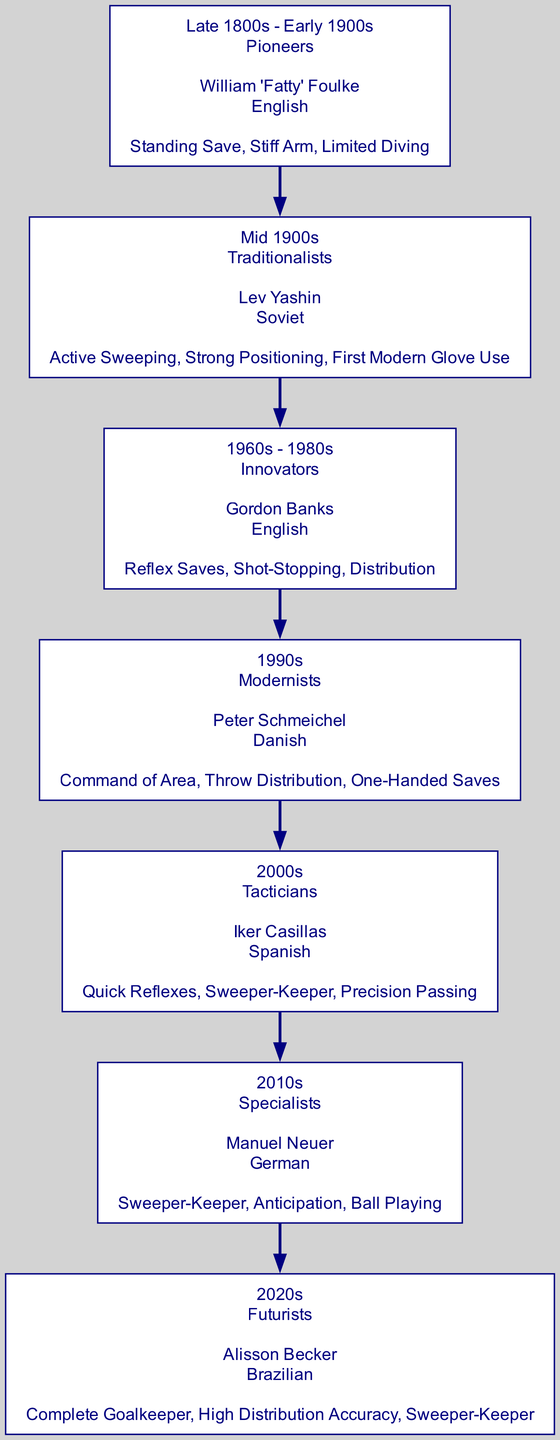What is the technique associated with William 'Fatty' Foulke? The diagram shows that William 'Fatty' Foulke is associated with the techniques: Standing Save, Stiff Arm, Limited Diving, listed under the "Late 1800s - Early 1900s" era.
Answer: Standing Save, Stiff Arm, Limited Diving Who is identified as the Innovator in goalkeeping? According to the diagram, Gordon Banks is presented as the Innovator in the 1960s - 1980s era, where he is recognized for his contributions to goalkeeping.
Answer: Gordon Banks Which goalkeeper is noted for using the first modern gloves? The diagram indicates that Lev Yashin, a Traditionalist from the Mid 1900s, is noted for using the first modern gloves in goalkeeping.
Answer: Lev Yashin How many eras are represented in the diagram? By examining the diagram, we can count a total of seven distinct eras from the Late 1800s - Early 1900s to the 2020s, each represented in the family tree.
Answer: 7 What is the shared technique between Manuel Neuer and Iker Casillas? The diagram highlights that both Manuel Neuer and Iker Casillas are associated with the technique of "Sweeper-Keeper," thus demonstrating a commonality in their approach to goalkeeping.
Answer: Sweeper-Keeper Who is the Futurist goalkeeper in the diagram? The diagram specifies Alisson Becker as the Futurist goalkeeper in the 2020s, showcasing his contemporary techniques.
Answer: Alisson Becker Which goalkeeper has the technique of "High Distribution Accuracy"? In the diagram, Alisson Becker from the 2020s is defined to have the technique of "High Distribution Accuracy," as part of his skill set.
Answer: High Distribution Accuracy What era comes directly after the Modernists? The diagram delineates that the era that follows the Modernists in the timeline is the Tacticians, represented by Iker Casillas in the 2000s.
Answer: Tacticians Which nationality is associated with Peter Schmeichel? As denoted in the diagram, Peter Schmeichel is associated with the nationality Danish, which is stated prominently in his description.
Answer: Danish 